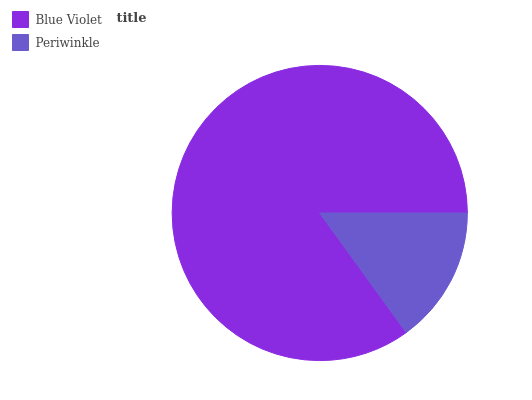Is Periwinkle the minimum?
Answer yes or no. Yes. Is Blue Violet the maximum?
Answer yes or no. Yes. Is Periwinkle the maximum?
Answer yes or no. No. Is Blue Violet greater than Periwinkle?
Answer yes or no. Yes. Is Periwinkle less than Blue Violet?
Answer yes or no. Yes. Is Periwinkle greater than Blue Violet?
Answer yes or no. No. Is Blue Violet less than Periwinkle?
Answer yes or no. No. Is Blue Violet the high median?
Answer yes or no. Yes. Is Periwinkle the low median?
Answer yes or no. Yes. Is Periwinkle the high median?
Answer yes or no. No. Is Blue Violet the low median?
Answer yes or no. No. 